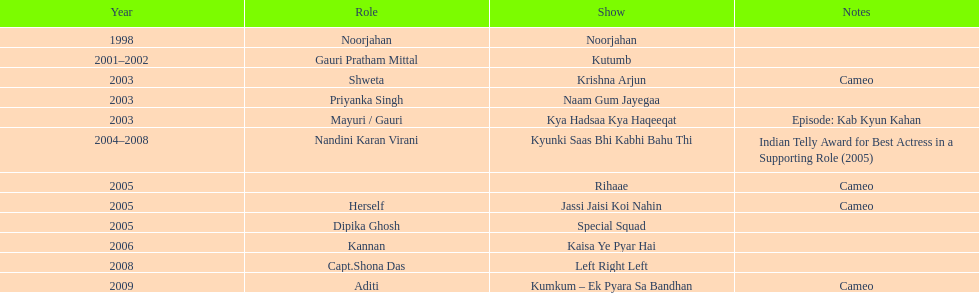Can you parse all the data within this table? {'header': ['Year', 'Role', 'Show', 'Notes'], 'rows': [['1998', 'Noorjahan', 'Noorjahan', ''], ['2001–2002', 'Gauri Pratham Mittal', 'Kutumb', ''], ['2003', 'Shweta', 'Krishna Arjun', 'Cameo'], ['2003', 'Priyanka Singh', 'Naam Gum Jayegaa', ''], ['2003', 'Mayuri / Gauri', 'Kya Hadsaa Kya Haqeeqat', 'Episode: Kab Kyun Kahan'], ['2004–2008', 'Nandini Karan Virani', 'Kyunki Saas Bhi Kabhi Bahu Thi', 'Indian Telly Award for Best Actress in a Supporting Role (2005)'], ['2005', '', 'Rihaae', 'Cameo'], ['2005', 'Herself', 'Jassi Jaisi Koi Nahin', 'Cameo'], ['2005', 'Dipika Ghosh', 'Special Squad', ''], ['2006', 'Kannan', 'Kaisa Ye Pyar Hai', ''], ['2008', 'Capt.Shona Das', 'Left Right Left', ''], ['2009', 'Aditi', 'Kumkum – Ek Pyara Sa Bandhan', 'Cameo']]} What is the maximum number of years a show has run? 4. 